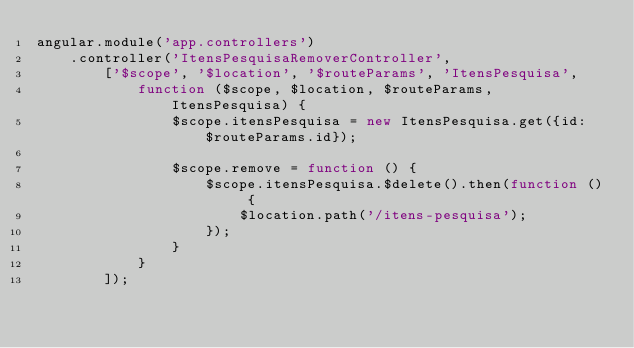<code> <loc_0><loc_0><loc_500><loc_500><_JavaScript_>angular.module('app.controllers')
    .controller('ItensPesquisaRemoverController',
        ['$scope', '$location', '$routeParams', 'ItensPesquisa',
            function ($scope, $location, $routeParams, ItensPesquisa) {
                $scope.itensPesquisa = new ItensPesquisa.get({id: $routeParams.id});

                $scope.remove = function () {
                    $scope.itensPesquisa.$delete().then(function () {
                        $location.path('/itens-pesquisa');
                    });
                }
            }
        ]);</code> 